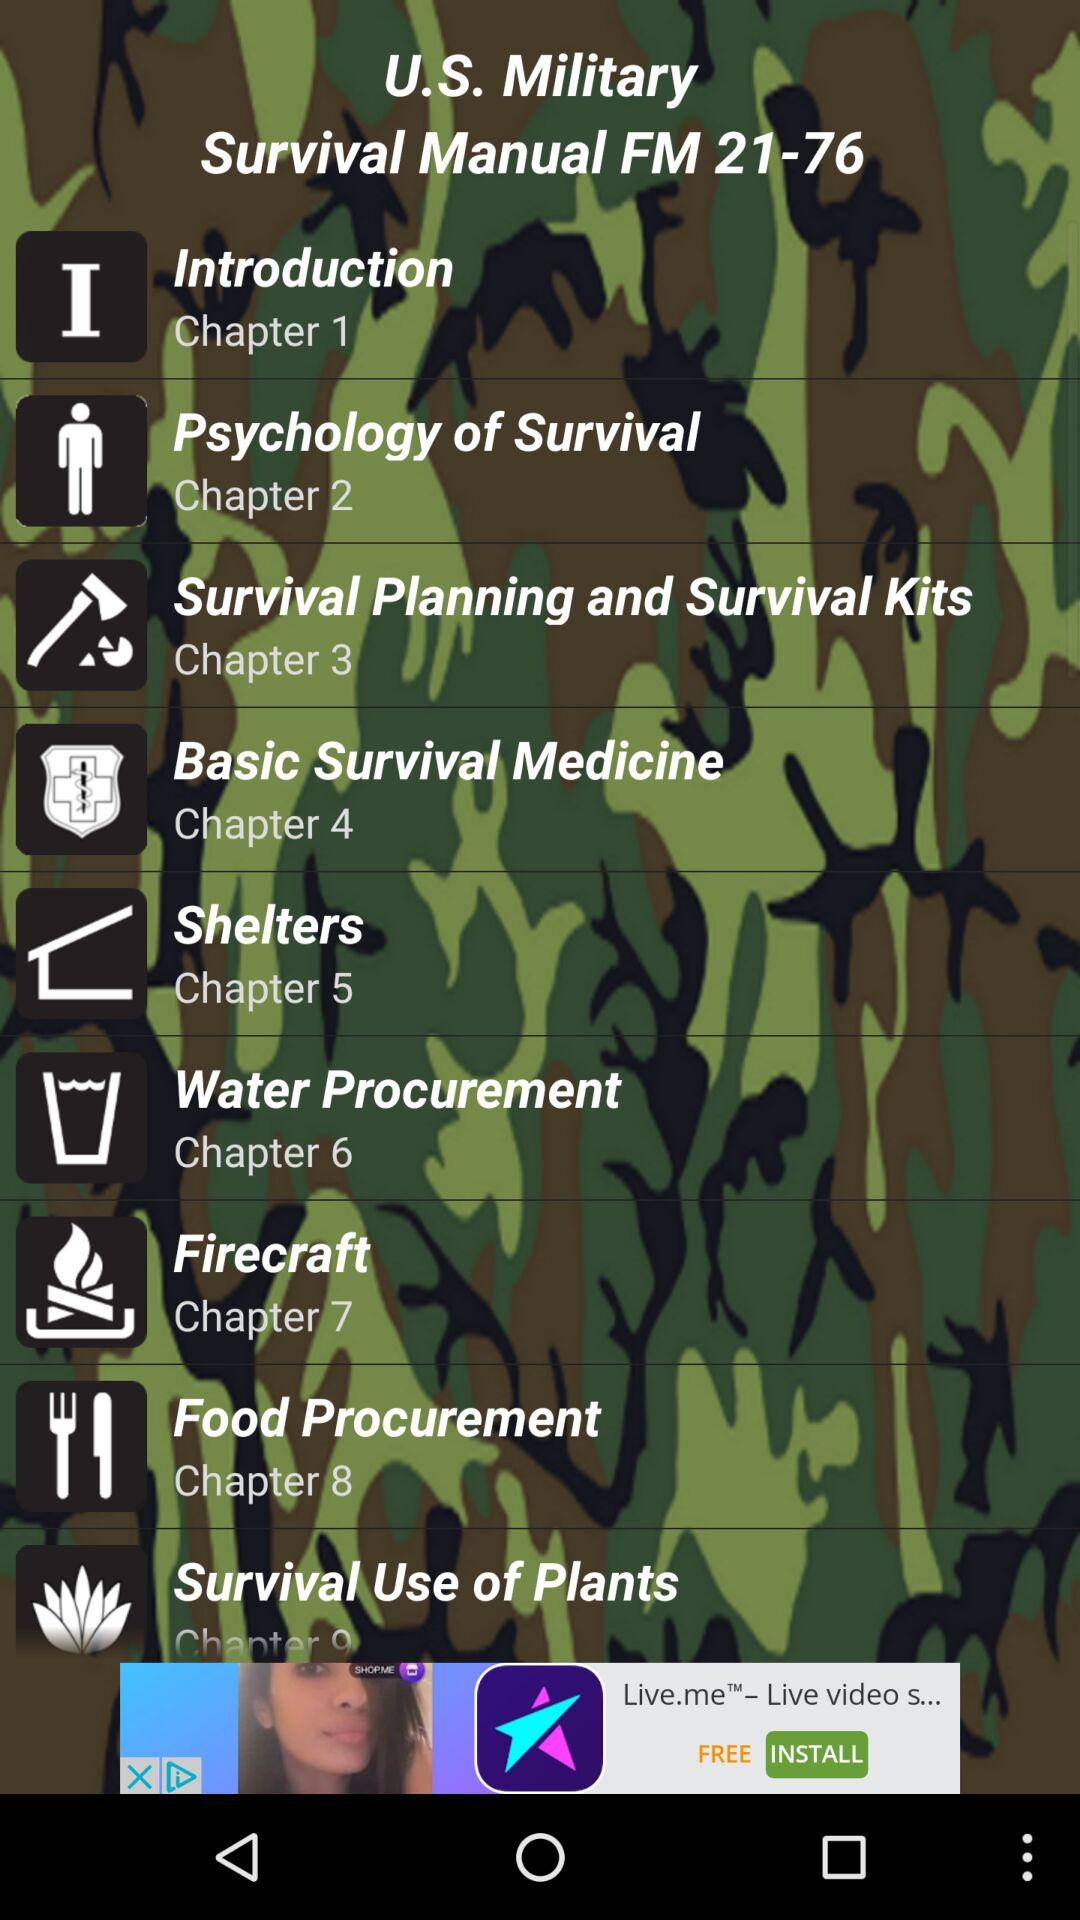How many chapters are there before Chapter 5?
Answer the question using a single word or phrase. 4 